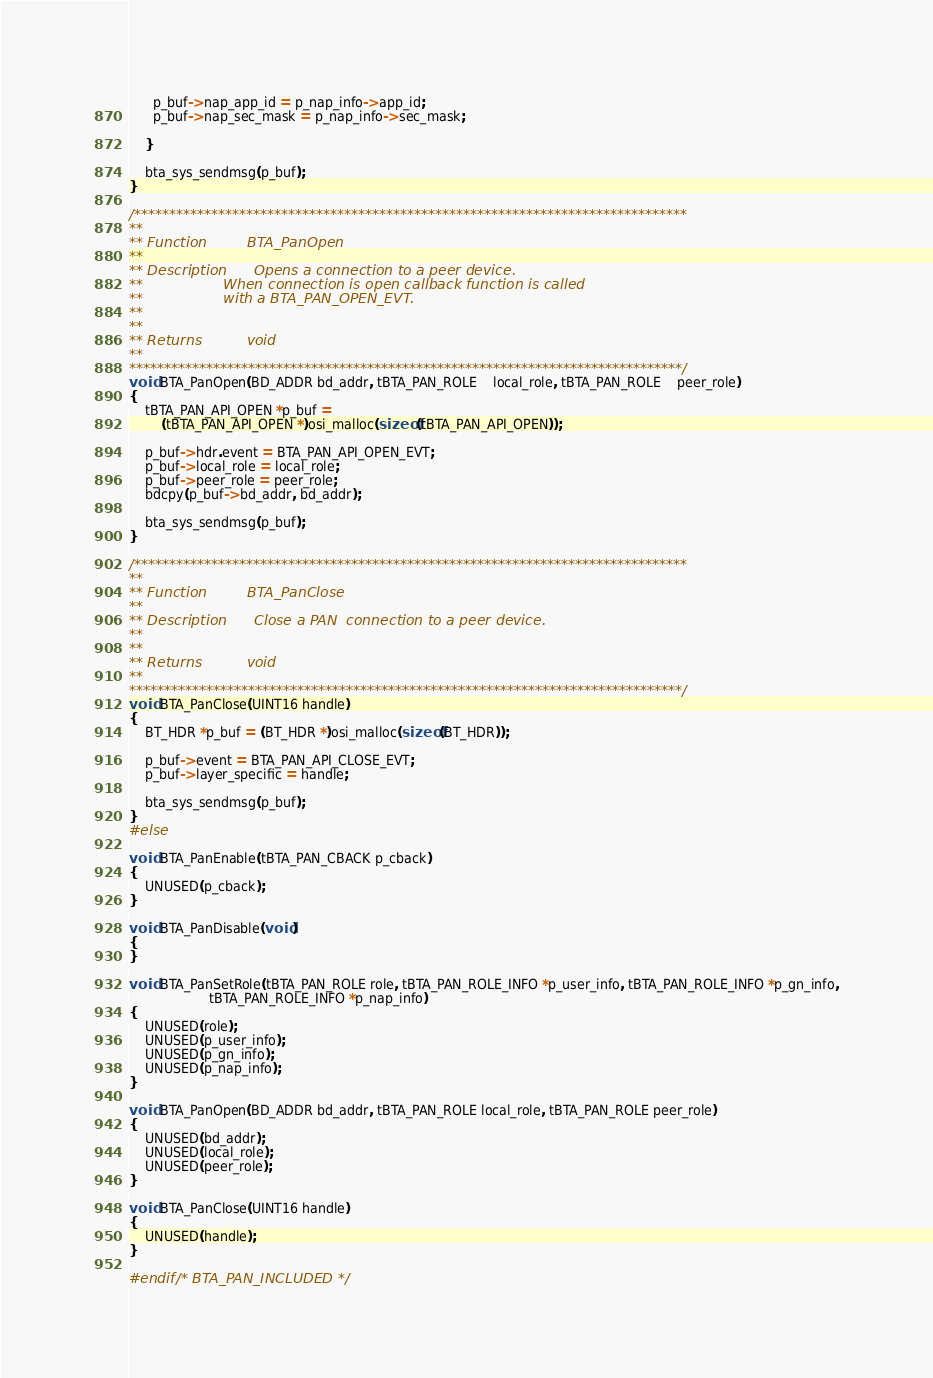Convert code to text. <code><loc_0><loc_0><loc_500><loc_500><_C_>
      p_buf->nap_app_id = p_nap_info->app_id;
      p_buf->nap_sec_mask = p_nap_info->sec_mask;

    }

    bta_sys_sendmsg(p_buf);
}

/*******************************************************************************
**
** Function         BTA_PanOpen
**
** Description      Opens a connection to a peer device.
**                  When connection is open callback function is called
**                  with a BTA_PAN_OPEN_EVT.
**
**
** Returns          void
**
*******************************************************************************/
void BTA_PanOpen(BD_ADDR bd_addr, tBTA_PAN_ROLE    local_role, tBTA_PAN_ROLE    peer_role)
{
    tBTA_PAN_API_OPEN *p_buf =
        (tBTA_PAN_API_OPEN *)osi_malloc(sizeof(tBTA_PAN_API_OPEN));

    p_buf->hdr.event = BTA_PAN_API_OPEN_EVT;
    p_buf->local_role = local_role;
    p_buf->peer_role = peer_role;
    bdcpy(p_buf->bd_addr, bd_addr);

    bta_sys_sendmsg(p_buf);
}

/*******************************************************************************
**
** Function         BTA_PanClose
**
** Description      Close a PAN  connection to a peer device.
**
**
** Returns          void
**
*******************************************************************************/
void BTA_PanClose(UINT16 handle)
{
    BT_HDR *p_buf = (BT_HDR *)osi_malloc(sizeof(BT_HDR));

    p_buf->event = BTA_PAN_API_CLOSE_EVT;
    p_buf->layer_specific = handle;

    bta_sys_sendmsg(p_buf);
}
#else

void BTA_PanEnable(tBTA_PAN_CBACK p_cback)
{
    UNUSED(p_cback);
}

void BTA_PanDisable(void)
{
}

void BTA_PanSetRole(tBTA_PAN_ROLE role, tBTA_PAN_ROLE_INFO *p_user_info, tBTA_PAN_ROLE_INFO *p_gn_info,
                    tBTA_PAN_ROLE_INFO *p_nap_info)
{
    UNUSED(role);
    UNUSED(p_user_info);
    UNUSED(p_gn_info);
    UNUSED(p_nap_info);
}

void BTA_PanOpen(BD_ADDR bd_addr, tBTA_PAN_ROLE local_role, tBTA_PAN_ROLE peer_role)
{
    UNUSED(bd_addr);
    UNUSED(local_role);
    UNUSED(peer_role);
}

void BTA_PanClose(UINT16 handle)
{
    UNUSED(handle);
}

#endif /* BTA_PAN_INCLUDED */
</code> 